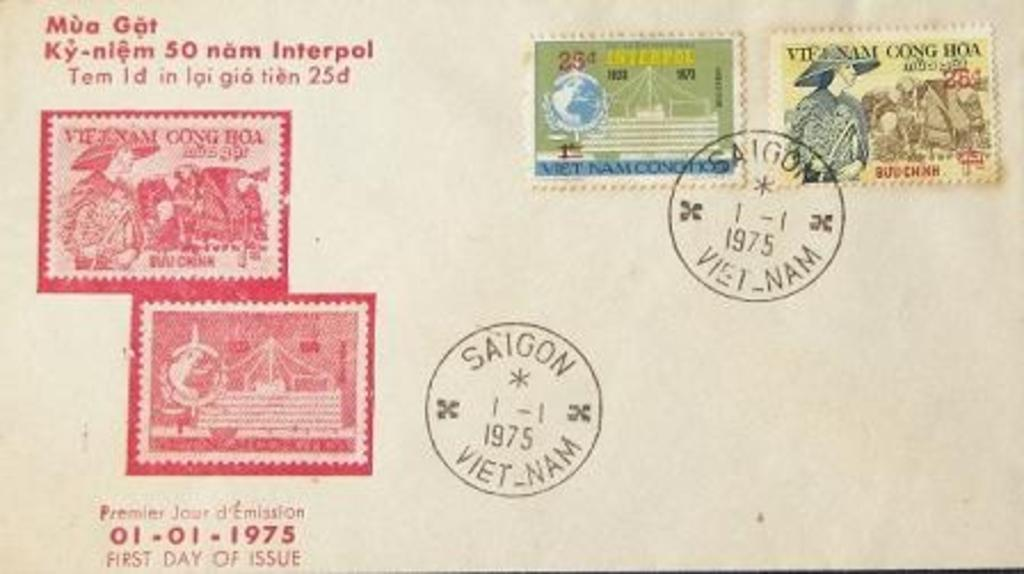<image>
Share a concise interpretation of the image provided. a Vietnamese envelope with stamps saying Saigon 1975 